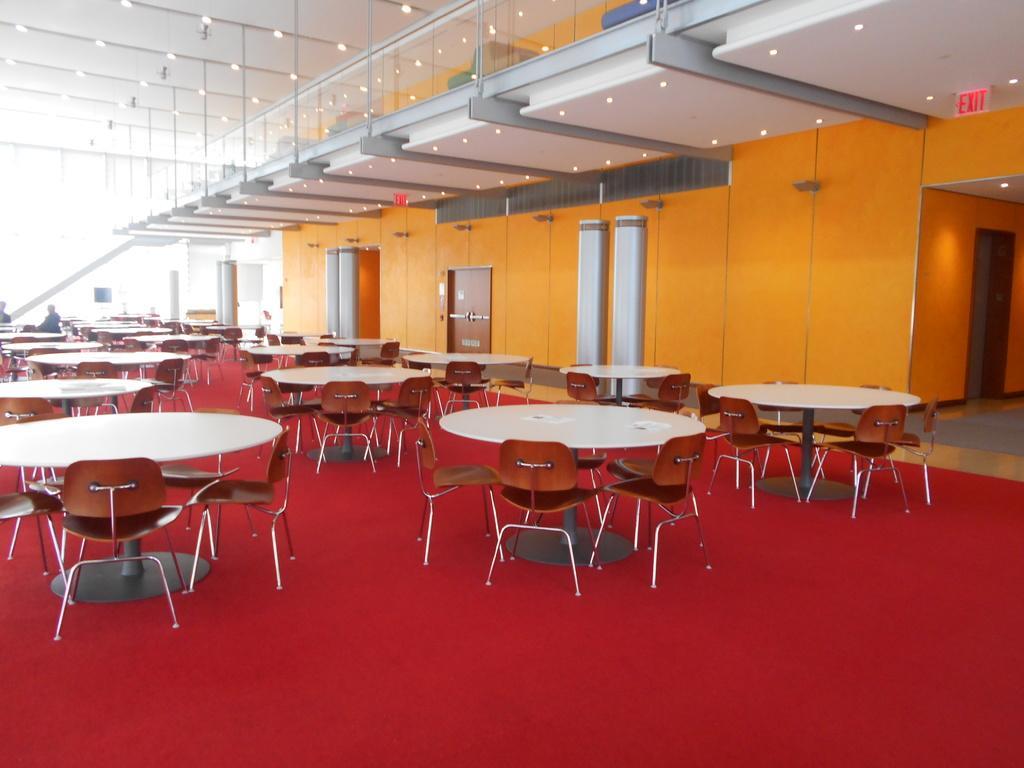Could you give a brief overview of what you see in this image? In this picture we can observe some tables and chairs. We can observe red color floor and and an orange color wall. We can observe a glass railing here and there are some lights. 